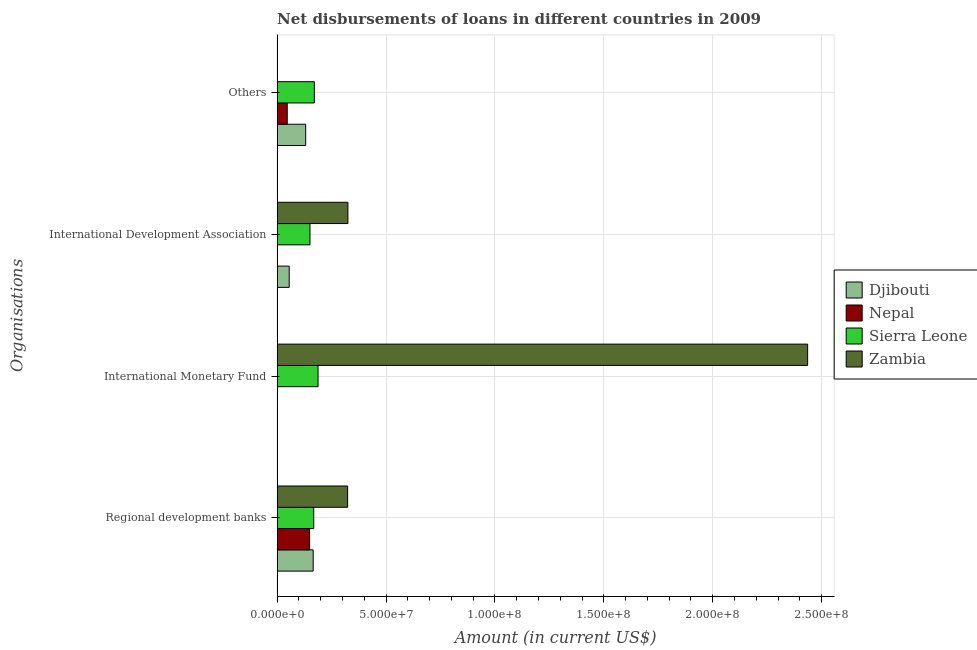How many groups of bars are there?
Offer a terse response. 4. Are the number of bars on each tick of the Y-axis equal?
Keep it short and to the point. No. How many bars are there on the 1st tick from the bottom?
Your answer should be compact. 4. What is the label of the 3rd group of bars from the top?
Provide a succinct answer. International Monetary Fund. What is the amount of loan disimbursed by international development association in Sierra Leone?
Provide a succinct answer. 1.51e+07. Across all countries, what is the maximum amount of loan disimbursed by international monetary fund?
Your answer should be very brief. 2.44e+08. Across all countries, what is the minimum amount of loan disimbursed by regional development banks?
Your response must be concise. 1.49e+07. In which country was the amount of loan disimbursed by international development association maximum?
Give a very brief answer. Zambia. What is the total amount of loan disimbursed by regional development banks in the graph?
Your response must be concise. 8.06e+07. What is the difference between the amount of loan disimbursed by international development association in Zambia and that in Sierra Leone?
Your answer should be very brief. 1.74e+07. What is the difference between the amount of loan disimbursed by regional development banks in Djibouti and the amount of loan disimbursed by international development association in Sierra Leone?
Offer a terse response. 1.47e+06. What is the average amount of loan disimbursed by regional development banks per country?
Offer a very short reply. 2.02e+07. What is the difference between the amount of loan disimbursed by international development association and amount of loan disimbursed by regional development banks in Zambia?
Give a very brief answer. 1.40e+05. In how many countries, is the amount of loan disimbursed by international development association greater than 90000000 US$?
Provide a succinct answer. 0. What is the ratio of the amount of loan disimbursed by other organisations in Djibouti to that in Sierra Leone?
Your answer should be very brief. 0.77. What is the difference between the highest and the second highest amount of loan disimbursed by other organisations?
Keep it short and to the point. 3.97e+06. What is the difference between the highest and the lowest amount of loan disimbursed by international monetary fund?
Provide a short and direct response. 2.44e+08. In how many countries, is the amount of loan disimbursed by international development association greater than the average amount of loan disimbursed by international development association taken over all countries?
Give a very brief answer. 2. Is the sum of the amount of loan disimbursed by regional development banks in Nepal and Zambia greater than the maximum amount of loan disimbursed by international monetary fund across all countries?
Ensure brevity in your answer.  No. Is it the case that in every country, the sum of the amount of loan disimbursed by regional development banks and amount of loan disimbursed by international monetary fund is greater than the amount of loan disimbursed by international development association?
Give a very brief answer. Yes. How many bars are there?
Your response must be concise. 12. How many countries are there in the graph?
Provide a succinct answer. 4. What is the difference between two consecutive major ticks on the X-axis?
Offer a terse response. 5.00e+07. Does the graph contain any zero values?
Ensure brevity in your answer.  Yes. Does the graph contain grids?
Offer a terse response. Yes. Where does the legend appear in the graph?
Your response must be concise. Center right. How are the legend labels stacked?
Your answer should be very brief. Vertical. What is the title of the graph?
Your response must be concise. Net disbursements of loans in different countries in 2009. What is the label or title of the Y-axis?
Offer a terse response. Organisations. What is the Amount (in current US$) of Djibouti in Regional development banks?
Your answer should be very brief. 1.66e+07. What is the Amount (in current US$) in Nepal in Regional development banks?
Your response must be concise. 1.49e+07. What is the Amount (in current US$) of Sierra Leone in Regional development banks?
Make the answer very short. 1.68e+07. What is the Amount (in current US$) of Zambia in Regional development banks?
Provide a short and direct response. 3.24e+07. What is the Amount (in current US$) of Djibouti in International Monetary Fund?
Your answer should be very brief. 0. What is the Amount (in current US$) of Nepal in International Monetary Fund?
Offer a very short reply. 0. What is the Amount (in current US$) of Sierra Leone in International Monetary Fund?
Your answer should be compact. 1.88e+07. What is the Amount (in current US$) in Zambia in International Monetary Fund?
Give a very brief answer. 2.44e+08. What is the Amount (in current US$) in Djibouti in International Development Association?
Your answer should be very brief. 5.54e+06. What is the Amount (in current US$) in Nepal in International Development Association?
Your response must be concise. 0. What is the Amount (in current US$) of Sierra Leone in International Development Association?
Make the answer very short. 1.51e+07. What is the Amount (in current US$) of Zambia in International Development Association?
Your answer should be very brief. 3.25e+07. What is the Amount (in current US$) in Djibouti in Others?
Provide a succinct answer. 1.31e+07. What is the Amount (in current US$) in Nepal in Others?
Your answer should be compact. 4.65e+06. What is the Amount (in current US$) of Sierra Leone in Others?
Provide a short and direct response. 1.71e+07. Across all Organisations, what is the maximum Amount (in current US$) of Djibouti?
Your answer should be very brief. 1.66e+07. Across all Organisations, what is the maximum Amount (in current US$) of Nepal?
Provide a succinct answer. 1.49e+07. Across all Organisations, what is the maximum Amount (in current US$) of Sierra Leone?
Provide a short and direct response. 1.88e+07. Across all Organisations, what is the maximum Amount (in current US$) of Zambia?
Offer a very short reply. 2.44e+08. Across all Organisations, what is the minimum Amount (in current US$) of Nepal?
Offer a terse response. 0. Across all Organisations, what is the minimum Amount (in current US$) in Sierra Leone?
Offer a very short reply. 1.51e+07. What is the total Amount (in current US$) of Djibouti in the graph?
Provide a short and direct response. 3.52e+07. What is the total Amount (in current US$) of Nepal in the graph?
Give a very brief answer. 1.96e+07. What is the total Amount (in current US$) in Sierra Leone in the graph?
Give a very brief answer. 6.78e+07. What is the total Amount (in current US$) of Zambia in the graph?
Give a very brief answer. 3.08e+08. What is the difference between the Amount (in current US$) of Sierra Leone in Regional development banks and that in International Monetary Fund?
Make the answer very short. -1.99e+06. What is the difference between the Amount (in current US$) in Zambia in Regional development banks and that in International Monetary Fund?
Make the answer very short. -2.11e+08. What is the difference between the Amount (in current US$) of Djibouti in Regional development banks and that in International Development Association?
Ensure brevity in your answer.  1.10e+07. What is the difference between the Amount (in current US$) in Sierra Leone in Regional development banks and that in International Development Association?
Provide a short and direct response. 1.72e+06. What is the difference between the Amount (in current US$) in Zambia in Regional development banks and that in International Development Association?
Provide a succinct answer. -1.40e+05. What is the difference between the Amount (in current US$) of Djibouti in Regional development banks and that in Others?
Offer a very short reply. 3.44e+06. What is the difference between the Amount (in current US$) in Nepal in Regional development banks and that in Others?
Provide a succinct answer. 1.03e+07. What is the difference between the Amount (in current US$) of Sierra Leone in Regional development banks and that in Others?
Your response must be concise. -2.74e+05. What is the difference between the Amount (in current US$) of Sierra Leone in International Monetary Fund and that in International Development Association?
Keep it short and to the point. 3.71e+06. What is the difference between the Amount (in current US$) in Zambia in International Monetary Fund and that in International Development Association?
Give a very brief answer. 2.11e+08. What is the difference between the Amount (in current US$) of Sierra Leone in International Monetary Fund and that in Others?
Provide a short and direct response. 1.72e+06. What is the difference between the Amount (in current US$) in Djibouti in International Development Association and that in Others?
Your answer should be compact. -7.57e+06. What is the difference between the Amount (in current US$) of Sierra Leone in International Development Association and that in Others?
Your answer should be very brief. -1.99e+06. What is the difference between the Amount (in current US$) in Djibouti in Regional development banks and the Amount (in current US$) in Sierra Leone in International Monetary Fund?
Provide a short and direct response. -2.24e+06. What is the difference between the Amount (in current US$) in Djibouti in Regional development banks and the Amount (in current US$) in Zambia in International Monetary Fund?
Your answer should be very brief. -2.27e+08. What is the difference between the Amount (in current US$) in Nepal in Regional development banks and the Amount (in current US$) in Sierra Leone in International Monetary Fund?
Make the answer very short. -3.87e+06. What is the difference between the Amount (in current US$) in Nepal in Regional development banks and the Amount (in current US$) in Zambia in International Monetary Fund?
Make the answer very short. -2.29e+08. What is the difference between the Amount (in current US$) in Sierra Leone in Regional development banks and the Amount (in current US$) in Zambia in International Monetary Fund?
Your answer should be very brief. -2.27e+08. What is the difference between the Amount (in current US$) of Djibouti in Regional development banks and the Amount (in current US$) of Sierra Leone in International Development Association?
Provide a succinct answer. 1.47e+06. What is the difference between the Amount (in current US$) of Djibouti in Regional development banks and the Amount (in current US$) of Zambia in International Development Association?
Offer a terse response. -1.60e+07. What is the difference between the Amount (in current US$) of Nepal in Regional development banks and the Amount (in current US$) of Sierra Leone in International Development Association?
Your response must be concise. -1.63e+05. What is the difference between the Amount (in current US$) in Nepal in Regional development banks and the Amount (in current US$) in Zambia in International Development Association?
Keep it short and to the point. -1.76e+07. What is the difference between the Amount (in current US$) of Sierra Leone in Regional development banks and the Amount (in current US$) of Zambia in International Development Association?
Your answer should be very brief. -1.57e+07. What is the difference between the Amount (in current US$) in Djibouti in Regional development banks and the Amount (in current US$) in Nepal in Others?
Your answer should be very brief. 1.19e+07. What is the difference between the Amount (in current US$) in Djibouti in Regional development banks and the Amount (in current US$) in Sierra Leone in Others?
Your answer should be compact. -5.26e+05. What is the difference between the Amount (in current US$) in Nepal in Regional development banks and the Amount (in current US$) in Sierra Leone in Others?
Your answer should be very brief. -2.16e+06. What is the difference between the Amount (in current US$) in Sierra Leone in International Monetary Fund and the Amount (in current US$) in Zambia in International Development Association?
Keep it short and to the point. -1.37e+07. What is the difference between the Amount (in current US$) of Djibouti in International Development Association and the Amount (in current US$) of Nepal in Others?
Provide a succinct answer. 8.95e+05. What is the difference between the Amount (in current US$) of Djibouti in International Development Association and the Amount (in current US$) of Sierra Leone in Others?
Ensure brevity in your answer.  -1.15e+07. What is the average Amount (in current US$) of Djibouti per Organisations?
Offer a very short reply. 8.80e+06. What is the average Amount (in current US$) of Nepal per Organisations?
Give a very brief answer. 4.89e+06. What is the average Amount (in current US$) in Sierra Leone per Organisations?
Offer a terse response. 1.69e+07. What is the average Amount (in current US$) in Zambia per Organisations?
Your response must be concise. 7.71e+07. What is the difference between the Amount (in current US$) of Djibouti and Amount (in current US$) of Nepal in Regional development banks?
Give a very brief answer. 1.63e+06. What is the difference between the Amount (in current US$) in Djibouti and Amount (in current US$) in Sierra Leone in Regional development banks?
Provide a succinct answer. -2.52e+05. What is the difference between the Amount (in current US$) in Djibouti and Amount (in current US$) in Zambia in Regional development banks?
Provide a succinct answer. -1.58e+07. What is the difference between the Amount (in current US$) of Nepal and Amount (in current US$) of Sierra Leone in Regional development banks?
Give a very brief answer. -1.88e+06. What is the difference between the Amount (in current US$) of Nepal and Amount (in current US$) of Zambia in Regional development banks?
Keep it short and to the point. -1.74e+07. What is the difference between the Amount (in current US$) of Sierra Leone and Amount (in current US$) of Zambia in Regional development banks?
Offer a very short reply. -1.56e+07. What is the difference between the Amount (in current US$) in Sierra Leone and Amount (in current US$) in Zambia in International Monetary Fund?
Offer a terse response. -2.25e+08. What is the difference between the Amount (in current US$) of Djibouti and Amount (in current US$) of Sierra Leone in International Development Association?
Ensure brevity in your answer.  -9.54e+06. What is the difference between the Amount (in current US$) of Djibouti and Amount (in current US$) of Zambia in International Development Association?
Your answer should be compact. -2.70e+07. What is the difference between the Amount (in current US$) in Sierra Leone and Amount (in current US$) in Zambia in International Development Association?
Keep it short and to the point. -1.74e+07. What is the difference between the Amount (in current US$) of Djibouti and Amount (in current US$) of Nepal in Others?
Your response must be concise. 8.46e+06. What is the difference between the Amount (in current US$) in Djibouti and Amount (in current US$) in Sierra Leone in Others?
Provide a short and direct response. -3.97e+06. What is the difference between the Amount (in current US$) in Nepal and Amount (in current US$) in Sierra Leone in Others?
Give a very brief answer. -1.24e+07. What is the ratio of the Amount (in current US$) in Sierra Leone in Regional development banks to that in International Monetary Fund?
Provide a succinct answer. 0.89. What is the ratio of the Amount (in current US$) of Zambia in Regional development banks to that in International Monetary Fund?
Your response must be concise. 0.13. What is the ratio of the Amount (in current US$) of Djibouti in Regional development banks to that in International Development Association?
Make the answer very short. 2.99. What is the ratio of the Amount (in current US$) in Sierra Leone in Regional development banks to that in International Development Association?
Give a very brief answer. 1.11. What is the ratio of the Amount (in current US$) of Djibouti in Regional development banks to that in Others?
Make the answer very short. 1.26. What is the ratio of the Amount (in current US$) in Nepal in Regional development banks to that in Others?
Provide a succinct answer. 3.21. What is the ratio of the Amount (in current US$) in Sierra Leone in International Monetary Fund to that in International Development Association?
Offer a terse response. 1.25. What is the ratio of the Amount (in current US$) in Zambia in International Monetary Fund to that in International Development Association?
Offer a terse response. 7.49. What is the ratio of the Amount (in current US$) of Sierra Leone in International Monetary Fund to that in Others?
Your answer should be very brief. 1.1. What is the ratio of the Amount (in current US$) of Djibouti in International Development Association to that in Others?
Your answer should be very brief. 0.42. What is the ratio of the Amount (in current US$) in Sierra Leone in International Development Association to that in Others?
Your answer should be compact. 0.88. What is the difference between the highest and the second highest Amount (in current US$) in Djibouti?
Provide a succinct answer. 3.44e+06. What is the difference between the highest and the second highest Amount (in current US$) in Sierra Leone?
Your answer should be very brief. 1.72e+06. What is the difference between the highest and the second highest Amount (in current US$) in Zambia?
Your answer should be compact. 2.11e+08. What is the difference between the highest and the lowest Amount (in current US$) of Djibouti?
Your answer should be very brief. 1.66e+07. What is the difference between the highest and the lowest Amount (in current US$) of Nepal?
Your answer should be compact. 1.49e+07. What is the difference between the highest and the lowest Amount (in current US$) of Sierra Leone?
Offer a very short reply. 3.71e+06. What is the difference between the highest and the lowest Amount (in current US$) in Zambia?
Give a very brief answer. 2.44e+08. 